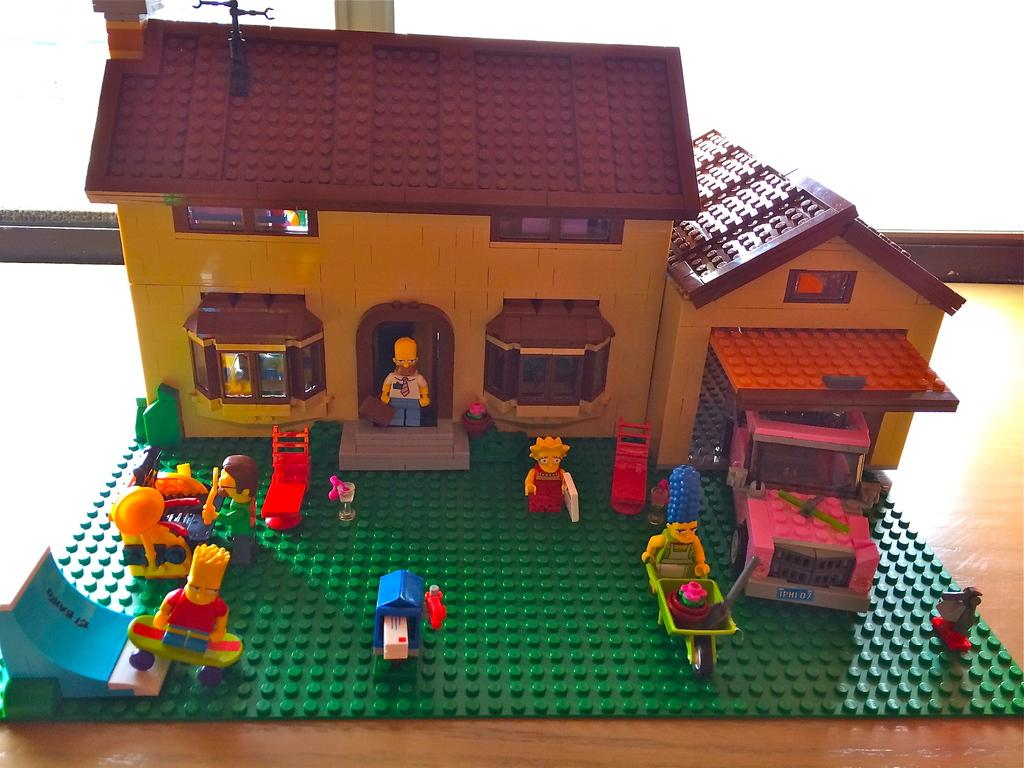What is the main subject in the center of the image? There is a toy house in the center of the image. What type of frog is wearing a vest in the image? There is no frog or vest present in the image; it only features a toy house. 